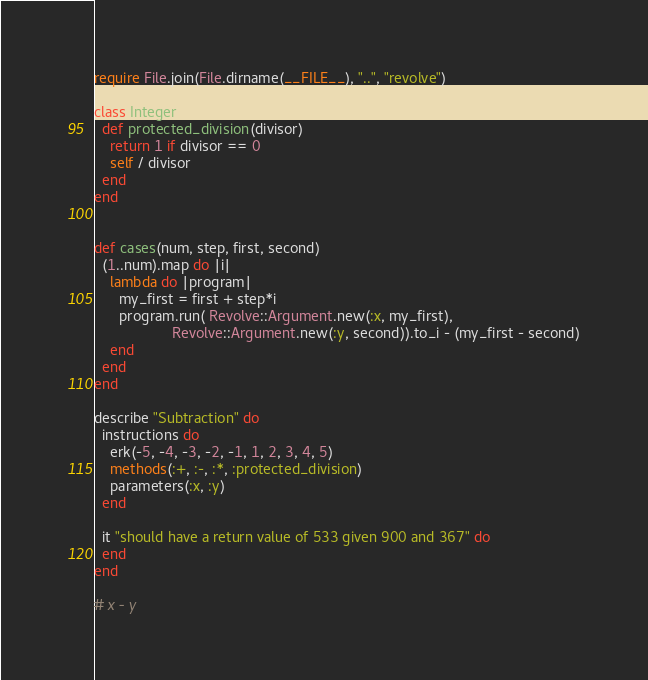<code> <loc_0><loc_0><loc_500><loc_500><_Ruby_>require File.join(File.dirname(__FILE__), "..", "revolve")

class Integer
  def protected_division(divisor)
    return 1 if divisor == 0
    self / divisor
  end
end


def cases(num, step, first, second)
  (1..num).map do |i|
    lambda do |program|
      my_first = first + step*i
      program.run( Revolve::Argument.new(:x, my_first), 
                   Revolve::Argument.new(:y, second)).to_i - (my_first - second)
    end
  end
end

describe "Subtraction" do  
  instructions do
    erk(-5, -4, -3, -2, -1, 1, 2, 3, 4, 5)
    methods(:+, :-, :*, :protected_division)
    parameters(:x, :y)
  end
  
  it "should have a return value of 533 given 900 and 367" do
  end
end

# x - y

</code> 